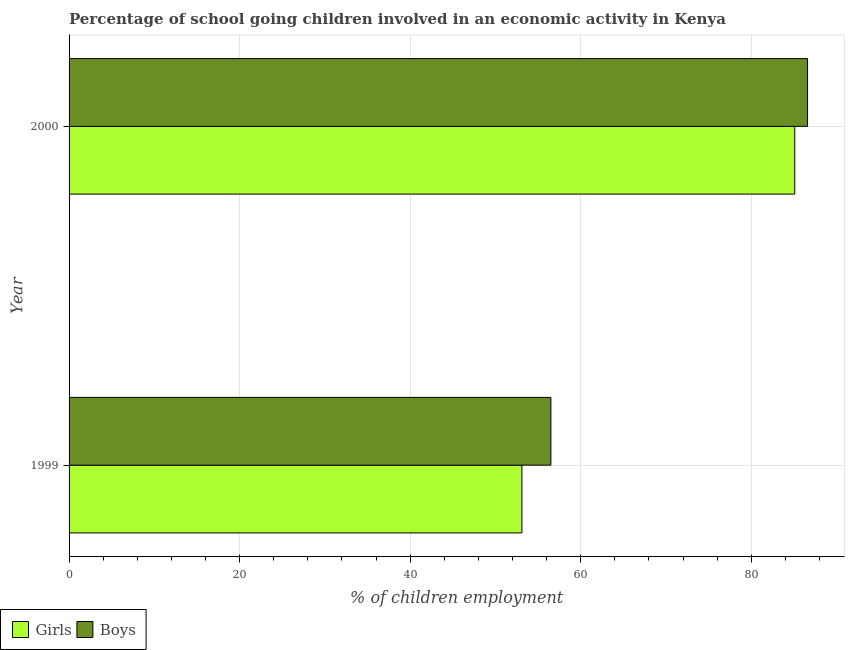Are the number of bars per tick equal to the number of legend labels?
Provide a short and direct response. Yes. How many bars are there on the 2nd tick from the top?
Offer a terse response. 2. How many bars are there on the 2nd tick from the bottom?
Keep it short and to the point. 2. What is the percentage of school going girls in 2000?
Ensure brevity in your answer.  85.1. Across all years, what is the maximum percentage of school going girls?
Offer a terse response. 85.1. Across all years, what is the minimum percentage of school going girls?
Keep it short and to the point. 53.1. What is the total percentage of school going girls in the graph?
Provide a succinct answer. 138.2. What is the difference between the percentage of school going girls in 1999 and that in 2000?
Provide a succinct answer. -32. What is the difference between the percentage of school going girls in 2000 and the percentage of school going boys in 1999?
Your answer should be very brief. 28.6. What is the average percentage of school going boys per year?
Provide a short and direct response. 71.55. In how many years, is the percentage of school going girls greater than 36 %?
Provide a short and direct response. 2. What is the ratio of the percentage of school going girls in 1999 to that in 2000?
Offer a very short reply. 0.62. Is the percentage of school going girls in 1999 less than that in 2000?
Your answer should be very brief. Yes. Is the difference between the percentage of school going girls in 1999 and 2000 greater than the difference between the percentage of school going boys in 1999 and 2000?
Offer a terse response. No. In how many years, is the percentage of school going girls greater than the average percentage of school going girls taken over all years?
Offer a very short reply. 1. What does the 2nd bar from the top in 1999 represents?
Your answer should be compact. Girls. What does the 2nd bar from the bottom in 1999 represents?
Your answer should be compact. Boys. What is the difference between two consecutive major ticks on the X-axis?
Provide a short and direct response. 20. Does the graph contain any zero values?
Ensure brevity in your answer.  No. Where does the legend appear in the graph?
Ensure brevity in your answer.  Bottom left. How many legend labels are there?
Your answer should be compact. 2. What is the title of the graph?
Your answer should be very brief. Percentage of school going children involved in an economic activity in Kenya. What is the label or title of the X-axis?
Your response must be concise. % of children employment. What is the % of children employment of Girls in 1999?
Your answer should be very brief. 53.1. What is the % of children employment of Boys in 1999?
Make the answer very short. 56.5. What is the % of children employment in Girls in 2000?
Provide a succinct answer. 85.1. What is the % of children employment in Boys in 2000?
Offer a very short reply. 86.6. Across all years, what is the maximum % of children employment in Girls?
Provide a short and direct response. 85.1. Across all years, what is the maximum % of children employment in Boys?
Ensure brevity in your answer.  86.6. Across all years, what is the minimum % of children employment in Girls?
Your answer should be very brief. 53.1. Across all years, what is the minimum % of children employment in Boys?
Offer a very short reply. 56.5. What is the total % of children employment in Girls in the graph?
Provide a short and direct response. 138.2. What is the total % of children employment of Boys in the graph?
Offer a very short reply. 143.1. What is the difference between the % of children employment in Girls in 1999 and that in 2000?
Offer a very short reply. -32. What is the difference between the % of children employment of Boys in 1999 and that in 2000?
Provide a succinct answer. -30.1. What is the difference between the % of children employment of Girls in 1999 and the % of children employment of Boys in 2000?
Keep it short and to the point. -33.5. What is the average % of children employment in Girls per year?
Your answer should be very brief. 69.1. What is the average % of children employment in Boys per year?
Provide a succinct answer. 71.55. In the year 1999, what is the difference between the % of children employment in Girls and % of children employment in Boys?
Ensure brevity in your answer.  -3.4. What is the ratio of the % of children employment in Girls in 1999 to that in 2000?
Ensure brevity in your answer.  0.62. What is the ratio of the % of children employment of Boys in 1999 to that in 2000?
Ensure brevity in your answer.  0.65. What is the difference between the highest and the second highest % of children employment of Boys?
Provide a short and direct response. 30.1. What is the difference between the highest and the lowest % of children employment in Boys?
Provide a succinct answer. 30.1. 